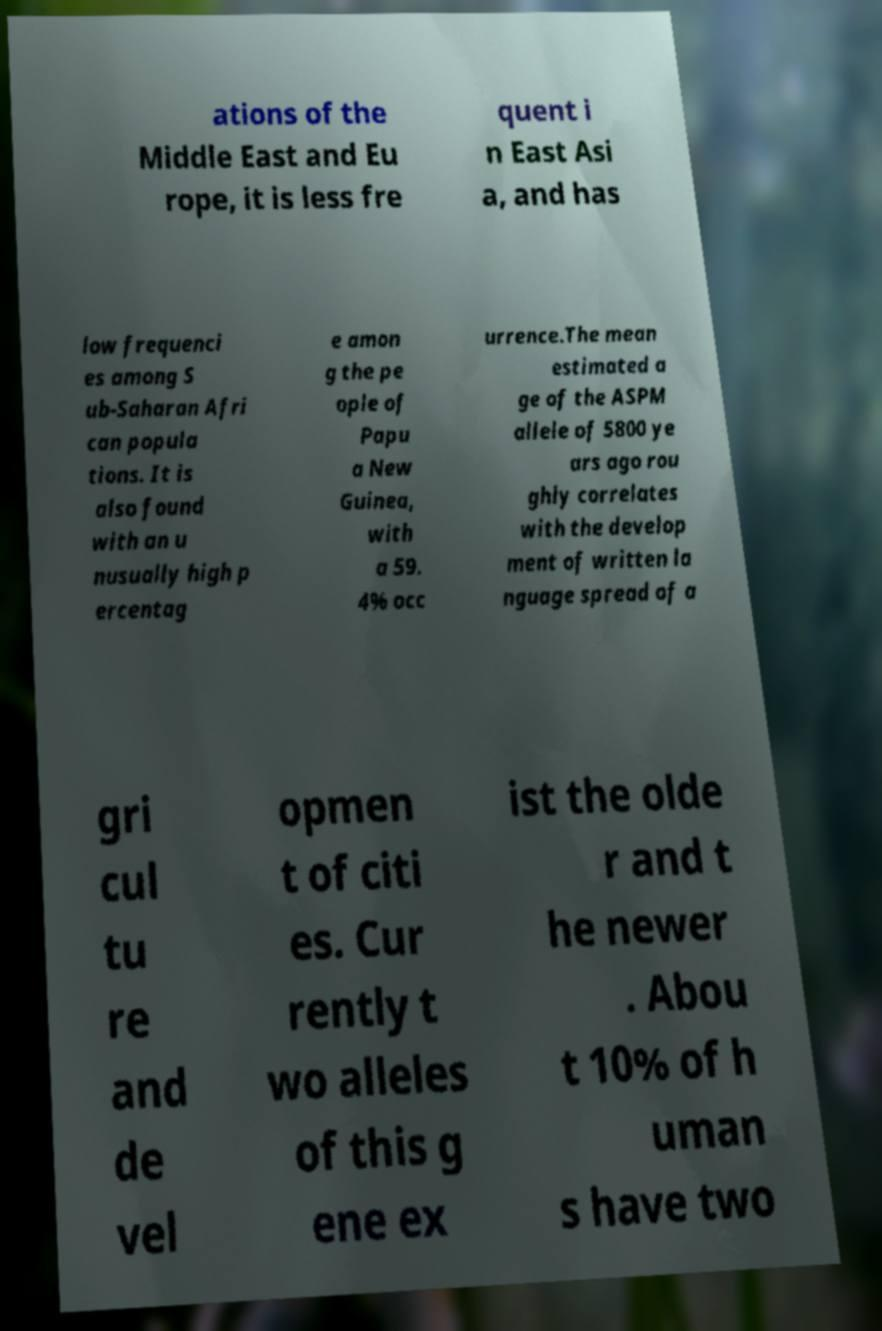Can you accurately transcribe the text from the provided image for me? ations of the Middle East and Eu rope, it is less fre quent i n East Asi a, and has low frequenci es among S ub-Saharan Afri can popula tions. It is also found with an u nusually high p ercentag e amon g the pe ople of Papu a New Guinea, with a 59. 4% occ urrence.The mean estimated a ge of the ASPM allele of 5800 ye ars ago rou ghly correlates with the develop ment of written la nguage spread of a gri cul tu re and de vel opmen t of citi es. Cur rently t wo alleles of this g ene ex ist the olde r and t he newer . Abou t 10% of h uman s have two 